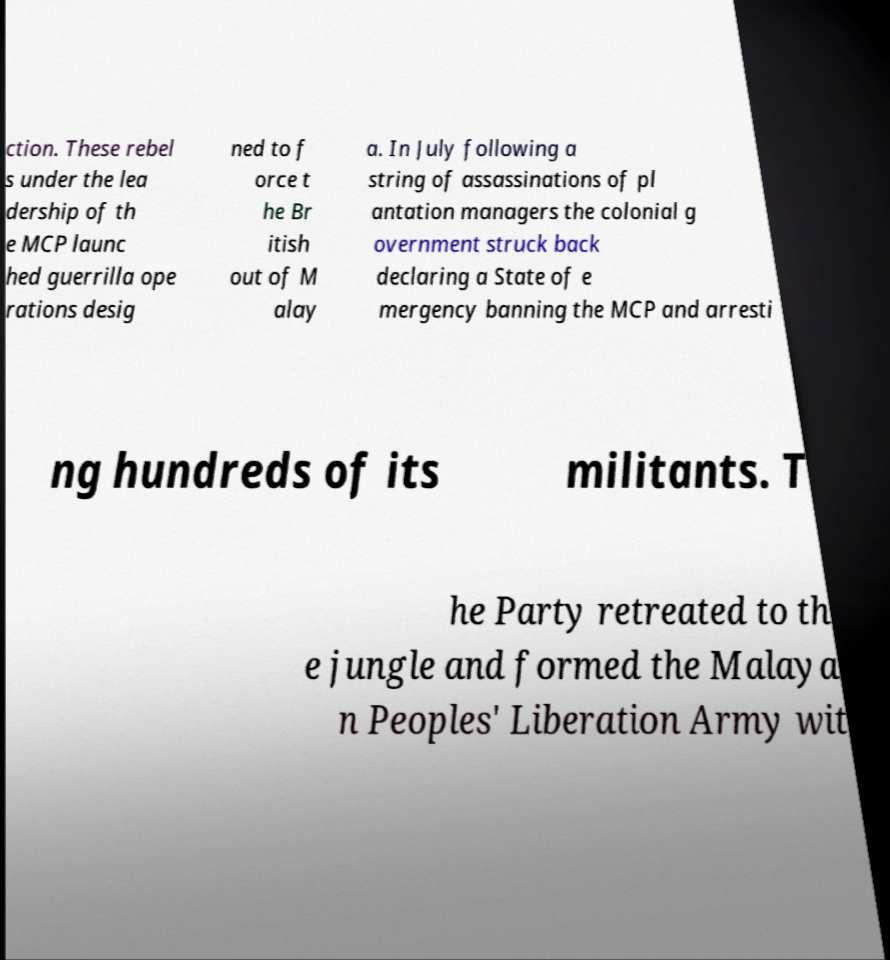Please read and relay the text visible in this image. What does it say? ction. These rebel s under the lea dership of th e MCP launc hed guerrilla ope rations desig ned to f orce t he Br itish out of M alay a. In July following a string of assassinations of pl antation managers the colonial g overnment struck back declaring a State of e mergency banning the MCP and arresti ng hundreds of its militants. T he Party retreated to th e jungle and formed the Malaya n Peoples' Liberation Army wit 